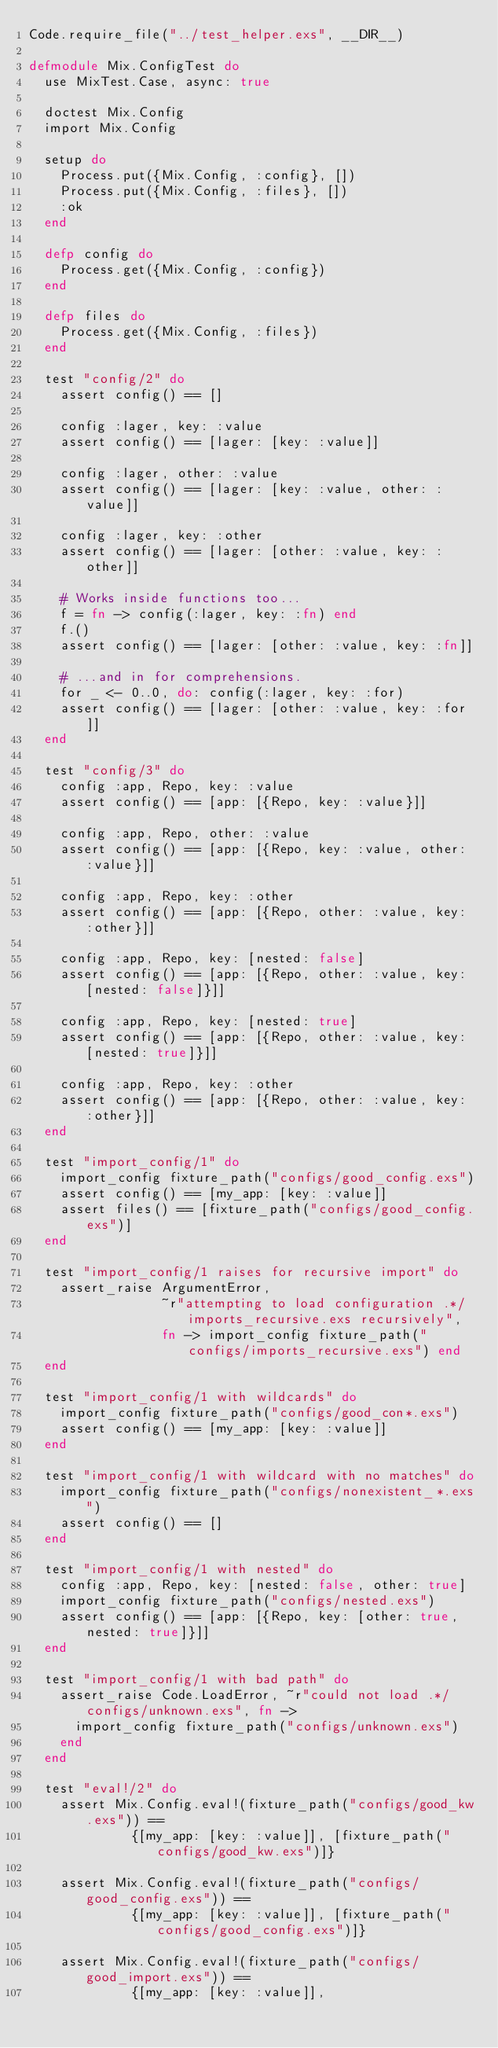Convert code to text. <code><loc_0><loc_0><loc_500><loc_500><_Elixir_>Code.require_file("../test_helper.exs", __DIR__)

defmodule Mix.ConfigTest do
  use MixTest.Case, async: true

  doctest Mix.Config
  import Mix.Config

  setup do
    Process.put({Mix.Config, :config}, [])
    Process.put({Mix.Config, :files}, [])
    :ok
  end

  defp config do
    Process.get({Mix.Config, :config})
  end

  defp files do
    Process.get({Mix.Config, :files})
  end

  test "config/2" do
    assert config() == []

    config :lager, key: :value
    assert config() == [lager: [key: :value]]

    config :lager, other: :value
    assert config() == [lager: [key: :value, other: :value]]

    config :lager, key: :other
    assert config() == [lager: [other: :value, key: :other]]

    # Works inside functions too...
    f = fn -> config(:lager, key: :fn) end
    f.()
    assert config() == [lager: [other: :value, key: :fn]]

    # ...and in for comprehensions.
    for _ <- 0..0, do: config(:lager, key: :for)
    assert config() == [lager: [other: :value, key: :for]]
  end

  test "config/3" do
    config :app, Repo, key: :value
    assert config() == [app: [{Repo, key: :value}]]

    config :app, Repo, other: :value
    assert config() == [app: [{Repo, key: :value, other: :value}]]

    config :app, Repo, key: :other
    assert config() == [app: [{Repo, other: :value, key: :other}]]

    config :app, Repo, key: [nested: false]
    assert config() == [app: [{Repo, other: :value, key: [nested: false]}]]

    config :app, Repo, key: [nested: true]
    assert config() == [app: [{Repo, other: :value, key: [nested: true]}]]

    config :app, Repo, key: :other
    assert config() == [app: [{Repo, other: :value, key: :other}]]
  end

  test "import_config/1" do
    import_config fixture_path("configs/good_config.exs")
    assert config() == [my_app: [key: :value]]
    assert files() == [fixture_path("configs/good_config.exs")]
  end

  test "import_config/1 raises for recursive import" do
    assert_raise ArgumentError,
                 ~r"attempting to load configuration .*/imports_recursive.exs recursively",
                 fn -> import_config fixture_path("configs/imports_recursive.exs") end
  end

  test "import_config/1 with wildcards" do
    import_config fixture_path("configs/good_con*.exs")
    assert config() == [my_app: [key: :value]]
  end

  test "import_config/1 with wildcard with no matches" do
    import_config fixture_path("configs/nonexistent_*.exs")
    assert config() == []
  end

  test "import_config/1 with nested" do
    config :app, Repo, key: [nested: false, other: true]
    import_config fixture_path("configs/nested.exs")
    assert config() == [app: [{Repo, key: [other: true, nested: true]}]]
  end

  test "import_config/1 with bad path" do
    assert_raise Code.LoadError, ~r"could not load .*/configs/unknown.exs", fn ->
      import_config fixture_path("configs/unknown.exs")
    end
  end

  test "eval!/2" do
    assert Mix.Config.eval!(fixture_path("configs/good_kw.exs")) ==
             {[my_app: [key: :value]], [fixture_path("configs/good_kw.exs")]}

    assert Mix.Config.eval!(fixture_path("configs/good_config.exs")) ==
             {[my_app: [key: :value]], [fixture_path("configs/good_config.exs")]}

    assert Mix.Config.eval!(fixture_path("configs/good_import.exs")) ==
             {[my_app: [key: :value]],</code> 